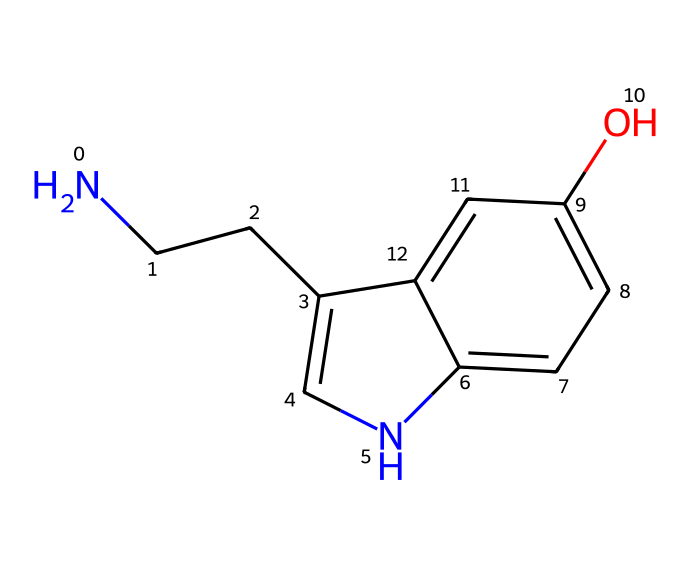What is the main functional group present in serotonin? The structure includes a hydroxyl group (-OH) indicated by the "O" in the SMILES notation, which is characteristic of alcohols.
Answer: hydroxyl How many nitrogen atoms are in serotonin? The SMILES representation shows one nitrogen atom (N) connected within the structure. There is no other occurrence of nitrogen depicted in the chemical.
Answer: one What is the total number of carbon atoms in serotonin? By analyzing the structure, we count a total of 10 carbon atoms that are represented in the SMILES (the "c" and "C" letters correspond to carbon).
Answer: ten Is serotonin a type of neurotransmitter or a hormone? Serotonin serves primarily as a neurotransmitter in the central nervous system for mood regulation.
Answer: neurotransmitter What effect does the presence of the hydroxyl group have on serotonin's solubility? The hydroxyl group enhances the molecule's polarity, which typically increases solubility in water.
Answer: increases solubility Which possibly aromatic ring is present in this structure? The structure contains a bicyclic aromatic system indicated by the presence of alternating single and double bonds in the ring structures and fused aromatic systems.
Answer: bicyclic aromatic Does serotonin have a basic or acidic character? The nitrogen atom in the structure can act as a base due to its lone pair of electrons, which can accept protons, indicating a basic characteristic.
Answer: basic 